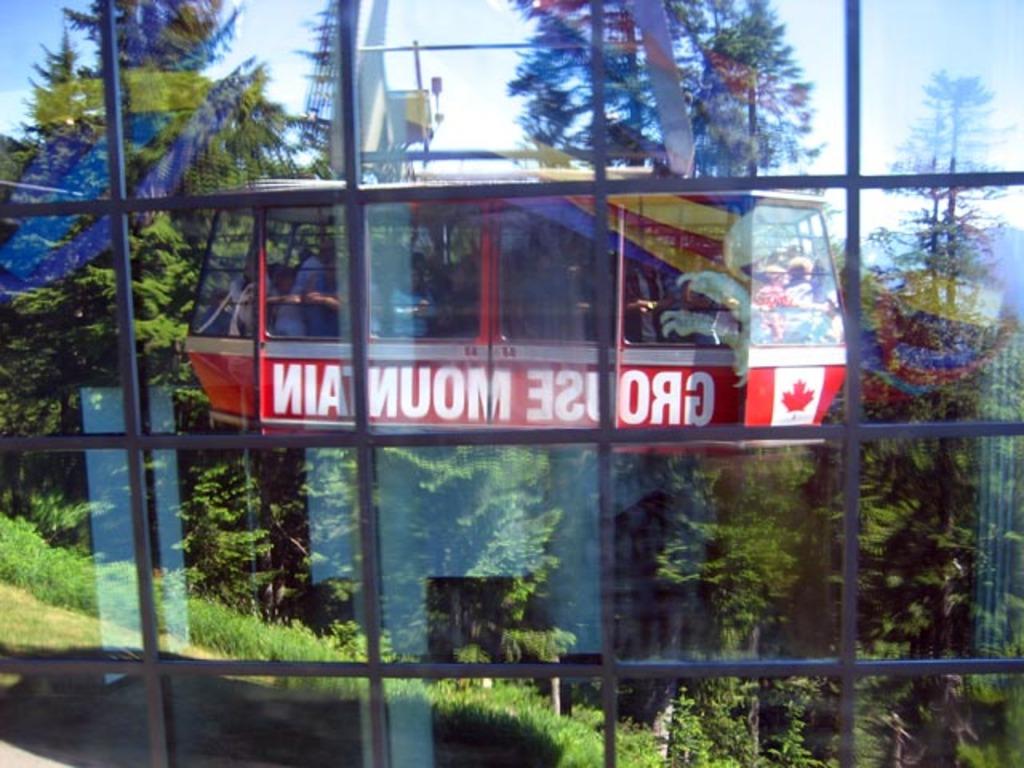What mountain is this located on?
Offer a terse response. Grouse. 